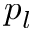Convert formula to latex. <formula><loc_0><loc_0><loc_500><loc_500>p _ { l }</formula> 